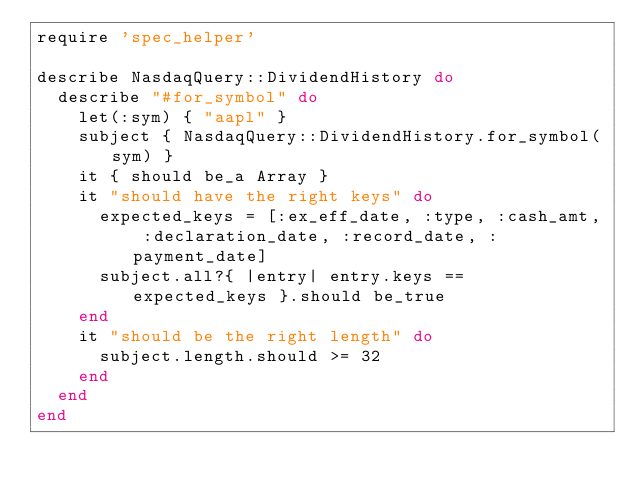<code> <loc_0><loc_0><loc_500><loc_500><_Ruby_>require 'spec_helper'

describe NasdaqQuery::DividendHistory do
  describe "#for_symbol" do
    let(:sym) { "aapl" }
    subject { NasdaqQuery::DividendHistory.for_symbol(sym) }
    it { should be_a Array }
    it "should have the right keys" do
      expected_keys = [:ex_eff_date, :type, :cash_amt, :declaration_date, :record_date, :payment_date]
      subject.all?{ |entry| entry.keys == expected_keys }.should be_true
    end
    it "should be the right length" do
      subject.length.should >= 32
    end
  end
end
</code> 